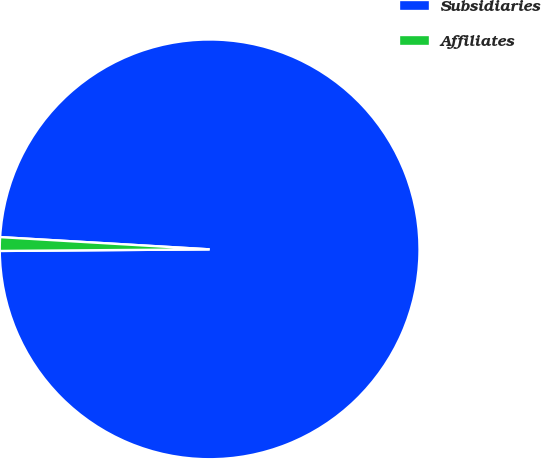Convert chart to OTSL. <chart><loc_0><loc_0><loc_500><loc_500><pie_chart><fcel>Subsidiaries<fcel>Affiliates<nl><fcel>98.95%<fcel>1.05%<nl></chart> 